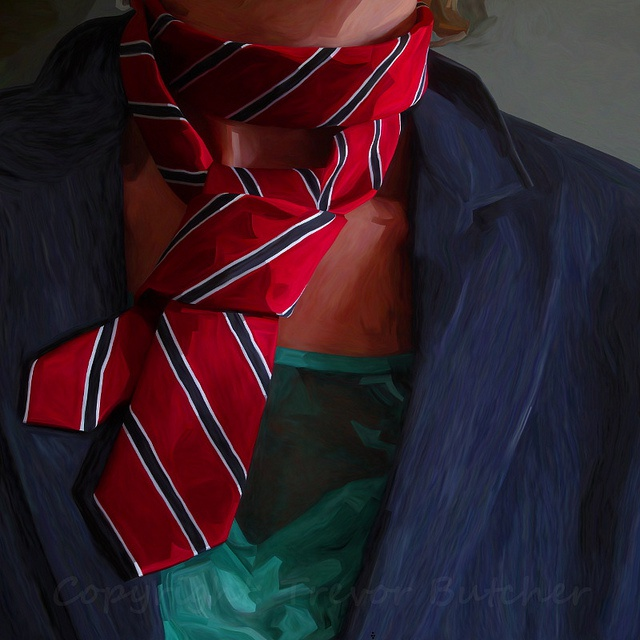Describe the objects in this image and their specific colors. I can see people in black, maroon, navy, and brown tones and tie in black, maroon, and brown tones in this image. 